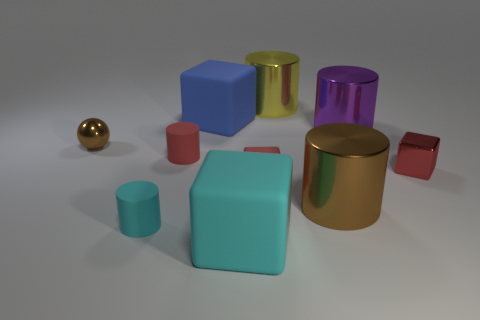Subtract all yellow cylinders. How many cylinders are left? 4 Subtract all red rubber cylinders. How many cylinders are left? 4 Subtract all green cylinders. Subtract all blue spheres. How many cylinders are left? 5 Subtract all balls. How many objects are left? 9 Add 5 big yellow shiny cylinders. How many big yellow shiny cylinders exist? 6 Subtract 1 blue blocks. How many objects are left? 9 Subtract all large rubber cubes. Subtract all blue matte blocks. How many objects are left? 7 Add 4 big yellow metal cylinders. How many big yellow metal cylinders are left? 5 